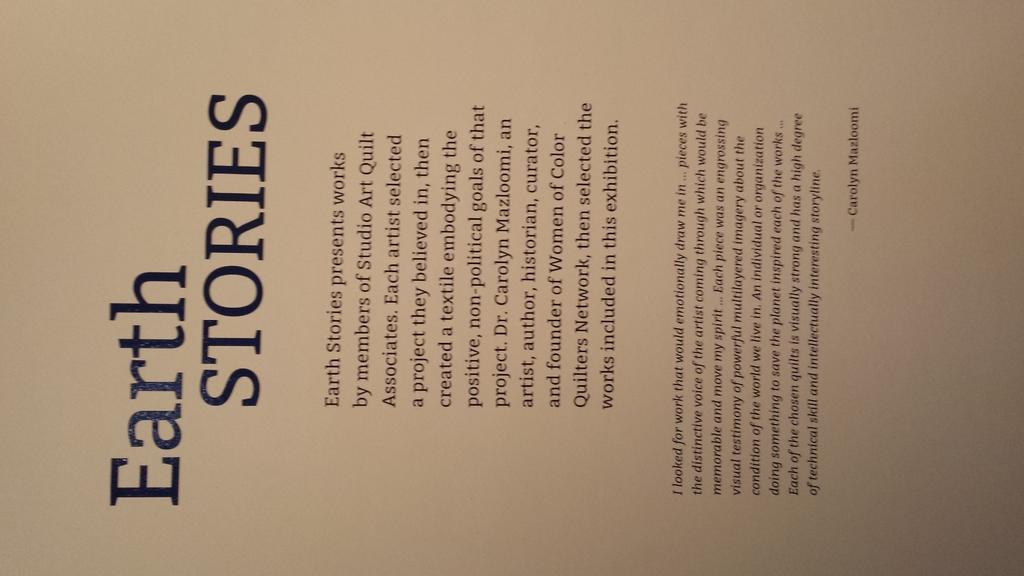<image>
Relay a brief, clear account of the picture shown. A typed page is labeled with the heading Earth Stories. 